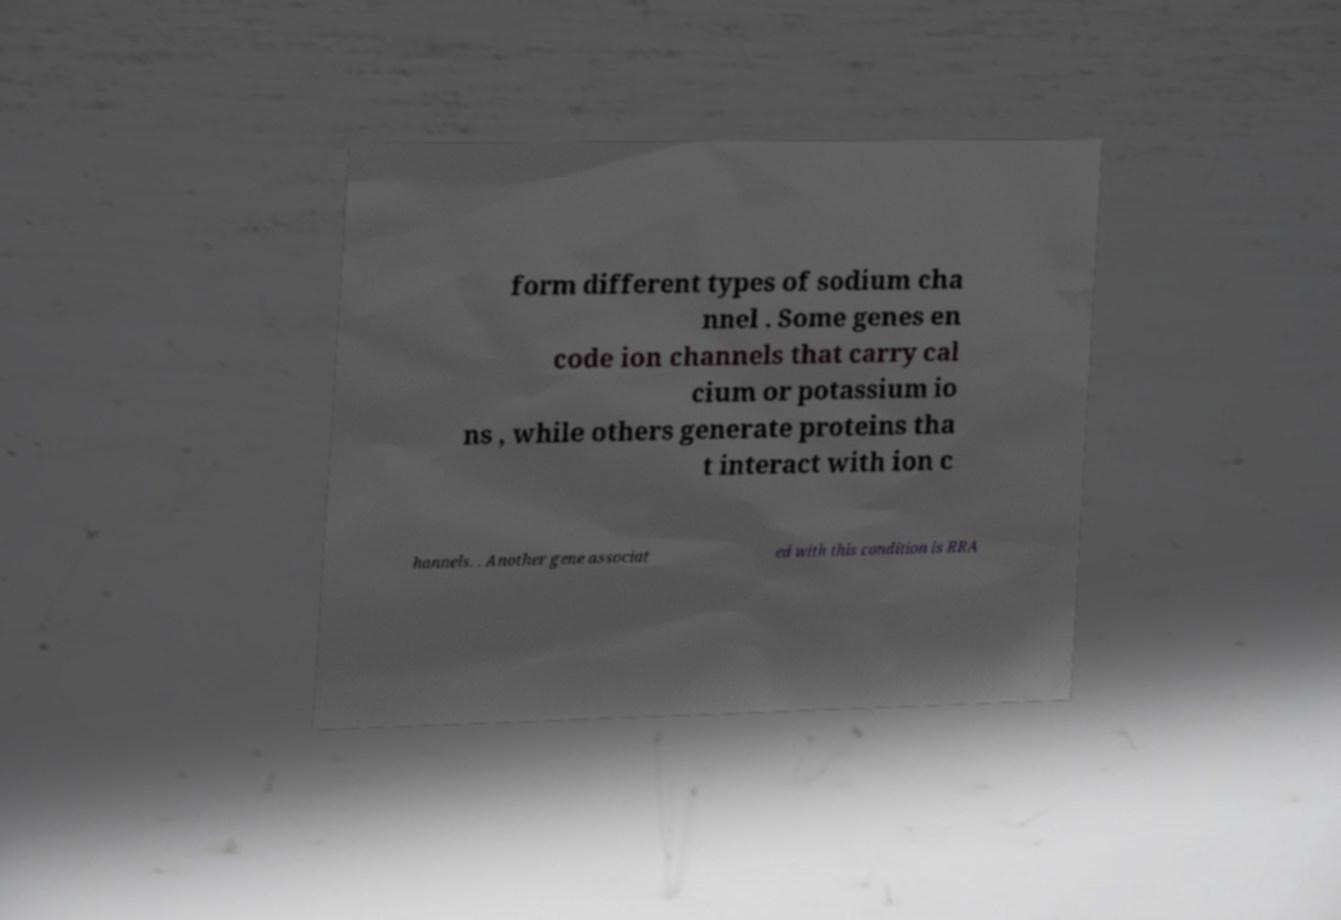I need the written content from this picture converted into text. Can you do that? form different types of sodium cha nnel . Some genes en code ion channels that carry cal cium or potassium io ns , while others generate proteins tha t interact with ion c hannels. . Another gene associat ed with this condition is RRA 